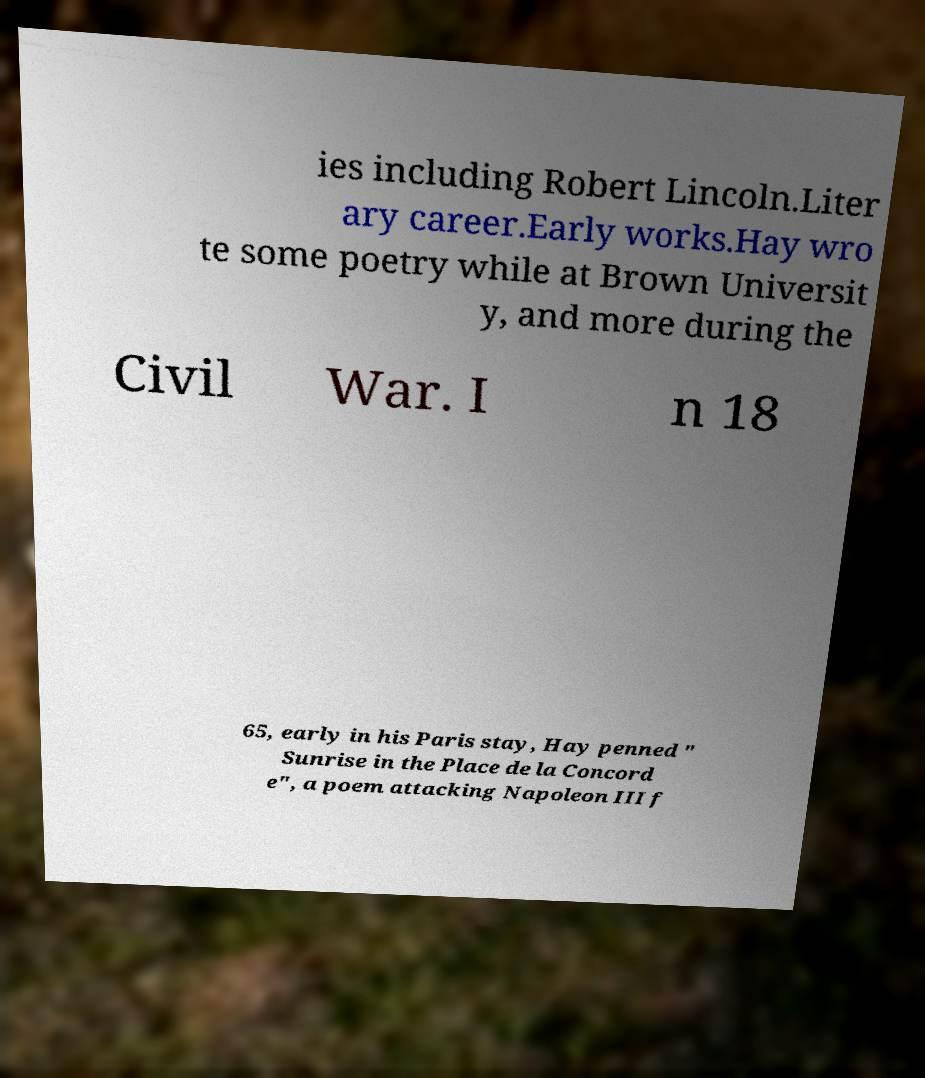For documentation purposes, I need the text within this image transcribed. Could you provide that? ies including Robert Lincoln.Liter ary career.Early works.Hay wro te some poetry while at Brown Universit y, and more during the Civil War. I n 18 65, early in his Paris stay, Hay penned " Sunrise in the Place de la Concord e", a poem attacking Napoleon III f 